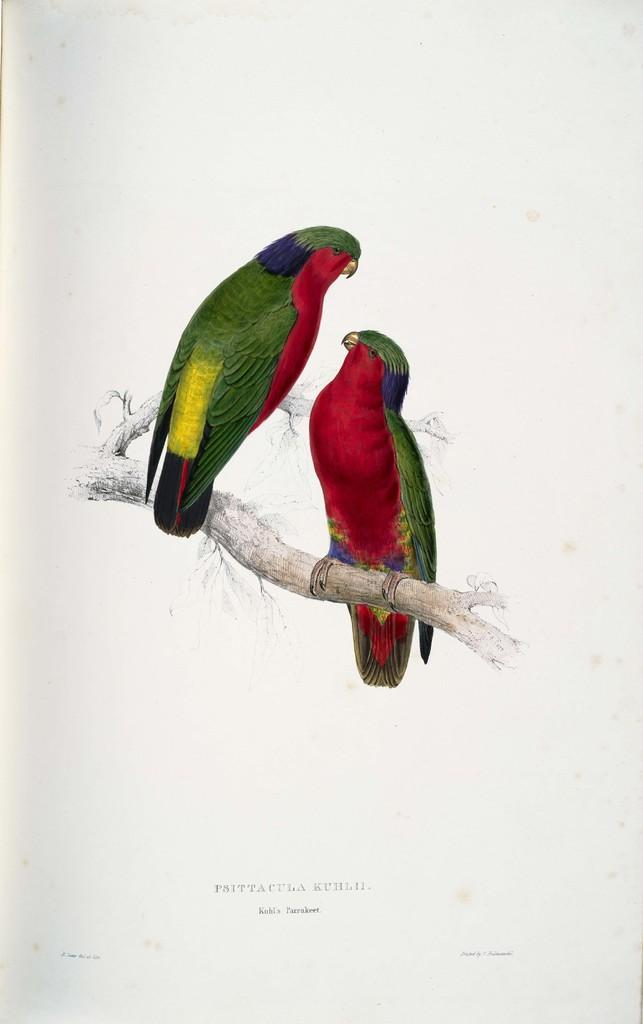What is the main subject of the image? There is a painting in the image. What is depicted in the painting? The painting depicts two birds. Where are the birds located in the painting? The birds are sitting on the stem of a tree. Is there any text present in the image? Yes, there is text written at the bottom of the image. What color is the hydrant in the image? There is no hydrant present in the image. What type of silver object can be seen in the painting? There is no silver object depicted in the painting; it features two birds sitting on the stem of a tree. 